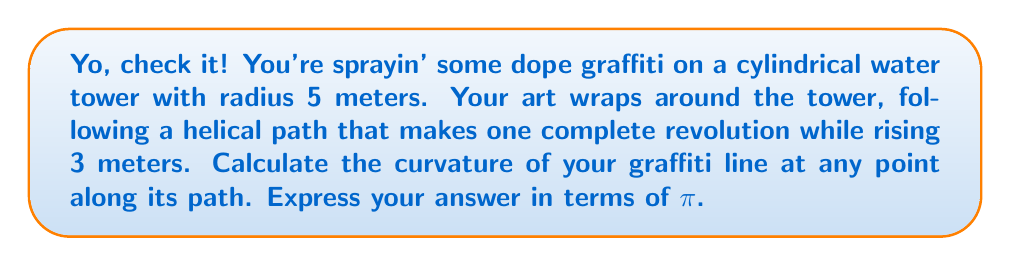Give your solution to this math problem. Alright, let's break this down step-by-step:

1) First, we need to parametrize the helical path. For a cylinder with radius $r$ and pitch $h$ (vertical rise per revolution), the parametric equations are:

   $x = r \cos(t)$
   $y = r \sin(t)$
   $z = \frac{h}{2\pi}t$

   where $t$ is the parameter (0 ≤ t ≤ 2π for one revolution).

2) In our case, $r = 5$ and $h = 3$. So our parametric equations are:

   $x = 5 \cos(t)$
   $y = 5 \sin(t)$
   $z = \frac{3}{2\pi}t$

3) To find the curvature, we need to calculate the first and second derivatives of these equations:

   $x' = -5 \sin(t)$, $x'' = -5 \cos(t)$
   $y' = 5 \cos(t)$, $y'' = -5 \sin(t)$
   $z' = \frac{3}{2\pi}$, $z'' = 0$

4) The curvature κ is given by the formula:

   $$\kappa = \frac{\sqrt{|\mathbf{r'} \times \mathbf{r''}|^2}}{|\mathbf{r'}|^3}$$

   where $\mathbf{r'}$ is the first derivative vector and $\mathbf{r''}$ is the second derivative vector.

5) Let's calculate $|\mathbf{r'}|$:

   $$|\mathbf{r'}| = \sqrt{(-5\sin(t))^2 + (5\cos(t))^2 + (\frac{3}{2\pi})^2} = \sqrt{25 + (\frac{3}{2\pi})^2}$$

6) Now, let's calculate $\mathbf{r'} \times \mathbf{r''}$:

   $$\mathbf{r'} \times \mathbf{r''} = \begin{vmatrix} 
   \mathbf{i} & \mathbf{j} & \mathbf{k} \\
   -5\sin(t) & 5\cos(t) & \frac{3}{2\pi} \\
   -5\cos(t) & -5\sin(t) & 0
   \end{vmatrix}$$

   $$= (-\frac{15}{2\pi}\sin(t))\mathbf{i} + (-\frac{15}{2\pi}\cos(t))\mathbf{j} + (25)\mathbf{k}$$

7) The magnitude of this cross product is:

   $$|\mathbf{r'} \times \mathbf{r''}| = \sqrt{(\frac{15}{2\pi})^2 + 25^2} = \sqrt{\frac{225}{4\pi^2} + 625}$$

8) Now we can plug these into our curvature formula:

   $$\kappa = \frac{\sqrt{\frac{225}{4\pi^2} + 625}}{(25 + (\frac{3}{2\pi})^2)^{3/2}}$$

9) This expression is constant (doesn't depend on t), which means the curvature is the same at all points along the helix.
Answer: $$\kappa = \frac{\sqrt{\frac{225}{4\pi^2} + 625}}{(25 + (\frac{3}{2\pi})^2)^{3/2}}$$ 